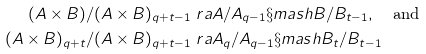Convert formula to latex. <formula><loc_0><loc_0><loc_500><loc_500>( A \times B ) / ( A \times B ) _ { q + t - 1 } & \ r a A / A _ { q - 1 } \S m a s h B / B _ { t - 1 } , \quad \text {and} \\ ( A \times B ) _ { q + t } / ( A \times B ) _ { q + t - 1 } & \ r a A _ { q } / A _ { q - 1 } \S m a s h B _ { t } / B _ { t - 1 }</formula> 